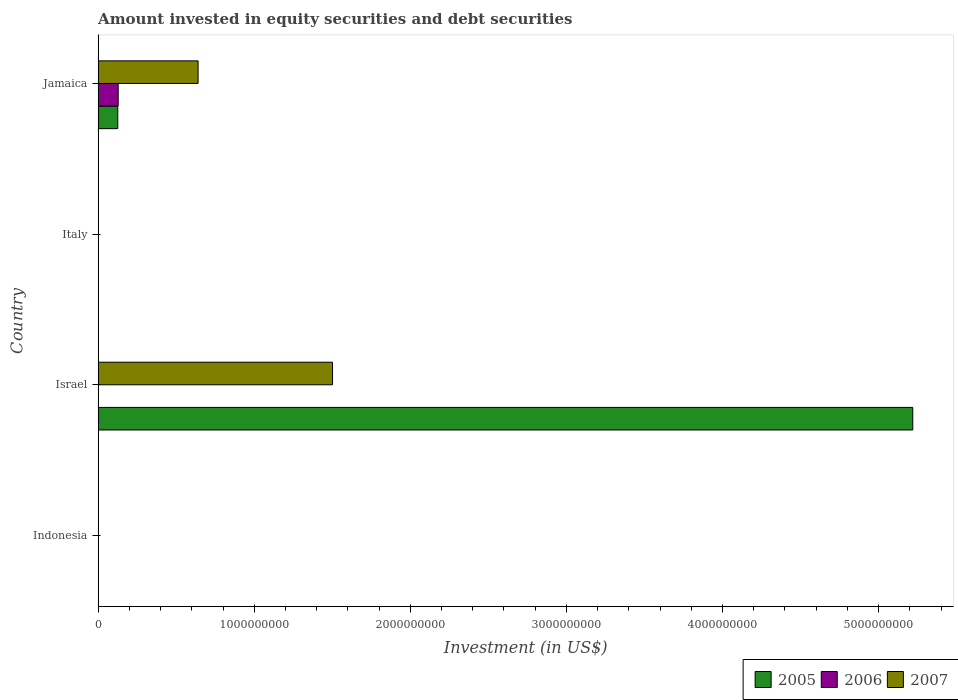Are the number of bars on each tick of the Y-axis equal?
Offer a very short reply. No. How many bars are there on the 2nd tick from the bottom?
Your answer should be very brief. 2. In how many cases, is the number of bars for a given country not equal to the number of legend labels?
Ensure brevity in your answer.  3. What is the amount invested in equity securities and debt securities in 2006 in Italy?
Offer a terse response. 0. Across all countries, what is the maximum amount invested in equity securities and debt securities in 2006?
Offer a terse response. 1.29e+08. In which country was the amount invested in equity securities and debt securities in 2005 maximum?
Your answer should be compact. Israel. What is the total amount invested in equity securities and debt securities in 2007 in the graph?
Make the answer very short. 2.14e+09. What is the difference between the amount invested in equity securities and debt securities in 2007 in Italy and the amount invested in equity securities and debt securities in 2006 in Jamaica?
Offer a very short reply. -1.29e+08. What is the average amount invested in equity securities and debt securities in 2007 per country?
Your answer should be compact. 5.36e+08. What is the difference between the amount invested in equity securities and debt securities in 2007 and amount invested in equity securities and debt securities in 2005 in Jamaica?
Offer a terse response. 5.14e+08. What is the ratio of the amount invested in equity securities and debt securities in 2007 in Israel to that in Jamaica?
Offer a terse response. 2.34. What is the difference between the highest and the lowest amount invested in equity securities and debt securities in 2005?
Your response must be concise. 5.22e+09. Is the sum of the amount invested in equity securities and debt securities in 2007 in Israel and Jamaica greater than the maximum amount invested in equity securities and debt securities in 2006 across all countries?
Your response must be concise. Yes. How many bars are there?
Your answer should be very brief. 5. Are all the bars in the graph horizontal?
Give a very brief answer. Yes. Does the graph contain any zero values?
Give a very brief answer. Yes. How many legend labels are there?
Your answer should be compact. 3. How are the legend labels stacked?
Make the answer very short. Horizontal. What is the title of the graph?
Provide a succinct answer. Amount invested in equity securities and debt securities. What is the label or title of the X-axis?
Offer a very short reply. Investment (in US$). What is the Investment (in US$) in 2005 in Indonesia?
Your answer should be compact. 0. What is the Investment (in US$) of 2006 in Indonesia?
Make the answer very short. 0. What is the Investment (in US$) of 2007 in Indonesia?
Provide a succinct answer. 0. What is the Investment (in US$) in 2005 in Israel?
Your answer should be very brief. 5.22e+09. What is the Investment (in US$) of 2006 in Israel?
Ensure brevity in your answer.  0. What is the Investment (in US$) in 2007 in Israel?
Provide a succinct answer. 1.50e+09. What is the Investment (in US$) of 2005 in Italy?
Your answer should be compact. 0. What is the Investment (in US$) in 2006 in Italy?
Keep it short and to the point. 0. What is the Investment (in US$) of 2005 in Jamaica?
Your answer should be compact. 1.26e+08. What is the Investment (in US$) of 2006 in Jamaica?
Your answer should be very brief. 1.29e+08. What is the Investment (in US$) of 2007 in Jamaica?
Ensure brevity in your answer.  6.40e+08. Across all countries, what is the maximum Investment (in US$) in 2005?
Your answer should be very brief. 5.22e+09. Across all countries, what is the maximum Investment (in US$) in 2006?
Offer a very short reply. 1.29e+08. Across all countries, what is the maximum Investment (in US$) in 2007?
Your answer should be very brief. 1.50e+09. Across all countries, what is the minimum Investment (in US$) of 2005?
Provide a succinct answer. 0. What is the total Investment (in US$) of 2005 in the graph?
Offer a terse response. 5.34e+09. What is the total Investment (in US$) in 2006 in the graph?
Make the answer very short. 1.29e+08. What is the total Investment (in US$) in 2007 in the graph?
Offer a very short reply. 2.14e+09. What is the difference between the Investment (in US$) in 2005 in Israel and that in Jamaica?
Your answer should be compact. 5.09e+09. What is the difference between the Investment (in US$) in 2007 in Israel and that in Jamaica?
Your answer should be very brief. 8.61e+08. What is the difference between the Investment (in US$) in 2005 in Israel and the Investment (in US$) in 2006 in Jamaica?
Offer a very short reply. 5.09e+09. What is the difference between the Investment (in US$) of 2005 in Israel and the Investment (in US$) of 2007 in Jamaica?
Your response must be concise. 4.58e+09. What is the average Investment (in US$) in 2005 per country?
Your response must be concise. 1.34e+09. What is the average Investment (in US$) of 2006 per country?
Make the answer very short. 3.21e+07. What is the average Investment (in US$) in 2007 per country?
Your response must be concise. 5.36e+08. What is the difference between the Investment (in US$) in 2005 and Investment (in US$) in 2007 in Israel?
Your answer should be very brief. 3.72e+09. What is the difference between the Investment (in US$) of 2005 and Investment (in US$) of 2006 in Jamaica?
Provide a succinct answer. -2.52e+06. What is the difference between the Investment (in US$) of 2005 and Investment (in US$) of 2007 in Jamaica?
Provide a succinct answer. -5.14e+08. What is the difference between the Investment (in US$) of 2006 and Investment (in US$) of 2007 in Jamaica?
Provide a short and direct response. -5.12e+08. What is the ratio of the Investment (in US$) of 2005 in Israel to that in Jamaica?
Provide a succinct answer. 41.42. What is the ratio of the Investment (in US$) of 2007 in Israel to that in Jamaica?
Provide a succinct answer. 2.34. What is the difference between the highest and the lowest Investment (in US$) of 2005?
Ensure brevity in your answer.  5.22e+09. What is the difference between the highest and the lowest Investment (in US$) in 2006?
Keep it short and to the point. 1.29e+08. What is the difference between the highest and the lowest Investment (in US$) in 2007?
Offer a very short reply. 1.50e+09. 